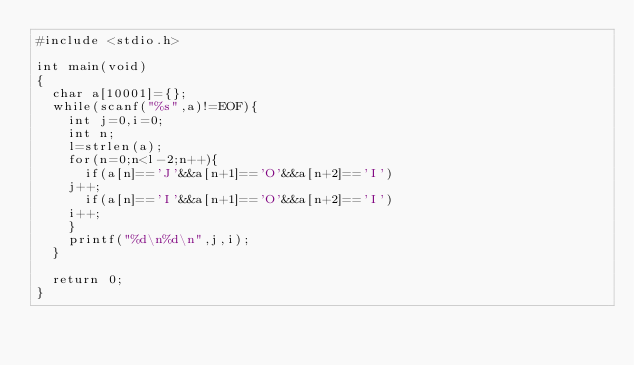<code> <loc_0><loc_0><loc_500><loc_500><_C_>#include <stdio.h>

int main(void)
{
  char a[10001]={}; 
  while(scanf("%s",a)!=EOF){
    int j=0,i=0;
    int n;
    l=strlen(a);
    for(n=0;n<l-2;n++){
      if(a[n]=='J'&&a[n+1]=='O'&&a[n+2]=='I')
	j++;
      if(a[n]=='I'&&a[n+1]=='O'&&a[n+2]=='I')
	i++;
    }
    printf("%d\n%d\n",j,i);
  }

  return 0;
}</code> 